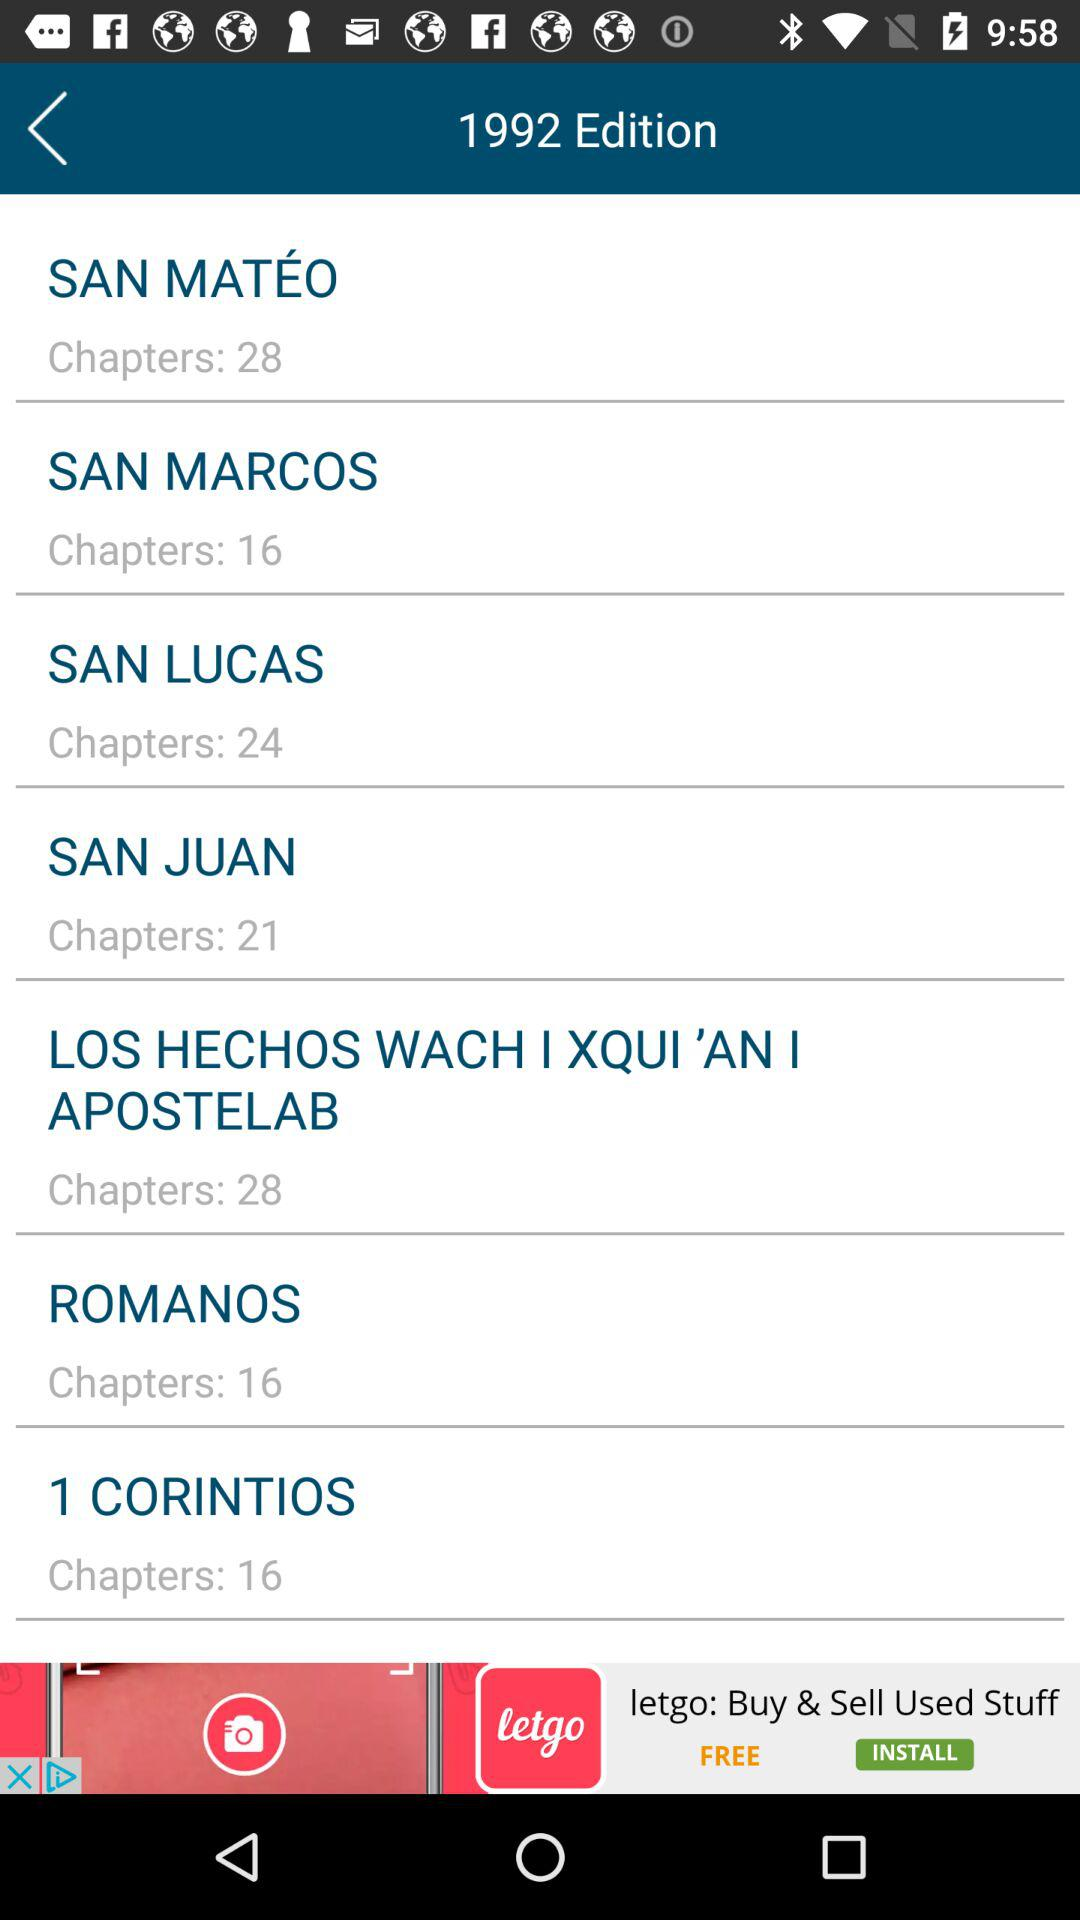How many chapters are in SAN LUCAS? There are 24 chapters. 